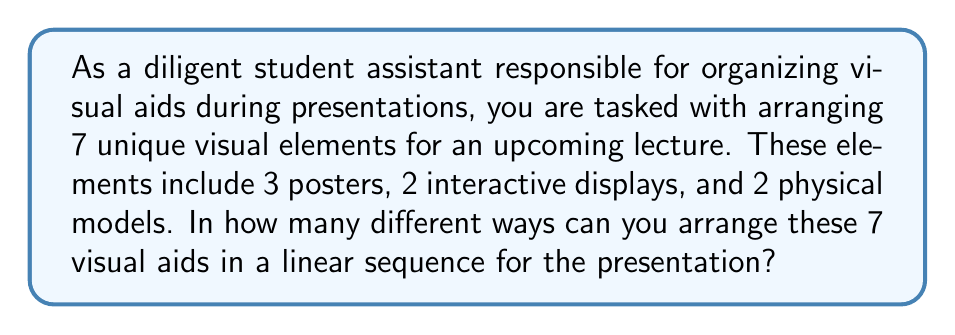What is the answer to this math problem? To solve this problem, we need to use the concept of permutations. Since all 7 visual aids are distinct, we are essentially finding the number of ways to arrange 7 unique objects.

The formula for permutations of n distinct objects is:

$$P(n) = n!$$

Where $n!$ represents the factorial of n.

In this case, $n = 7$, so we have:

$$P(7) = 7!$$

Let's calculate this step by step:

$$\begin{aligned}
7! &= 7 \times 6 \times 5 \times 4 \times 3 \times 2 \times 1 \\
   &= 5040
\end{aligned}$$

Therefore, there are 5040 different ways to arrange the 7 visual aids.

It's worth noting that this solution doesn't take into account the specific types of visual aids (posters, displays, models). If we wanted to consider these as distinct groups, we would use a different approach involving permutations with repetition. However, since the question states that all 7 elements are unique, we treat them as 7 distinct objects.
Answer: $5040$ 